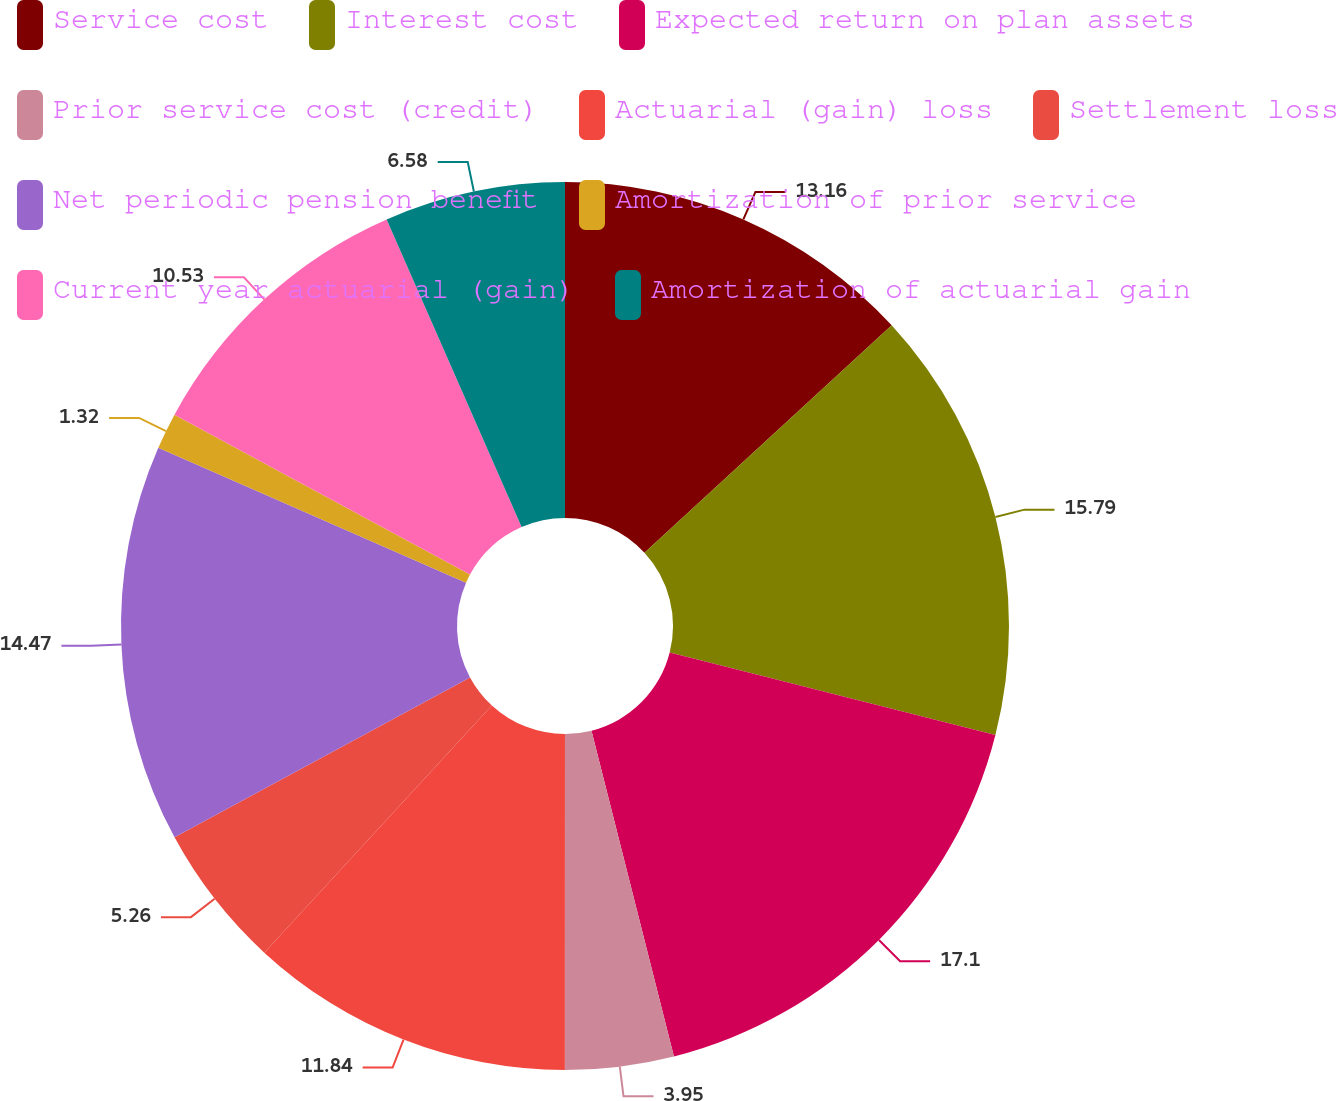Convert chart to OTSL. <chart><loc_0><loc_0><loc_500><loc_500><pie_chart><fcel>Service cost<fcel>Interest cost<fcel>Expected return on plan assets<fcel>Prior service cost (credit)<fcel>Actuarial (gain) loss<fcel>Settlement loss<fcel>Net periodic pension benefit<fcel>Amortization of prior service<fcel>Current year actuarial (gain)<fcel>Amortization of actuarial gain<nl><fcel>13.16%<fcel>15.79%<fcel>17.11%<fcel>3.95%<fcel>11.84%<fcel>5.26%<fcel>14.47%<fcel>1.32%<fcel>10.53%<fcel>6.58%<nl></chart> 